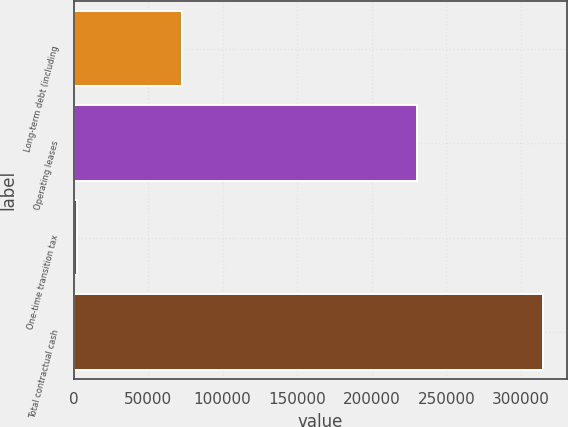Convert chart. <chart><loc_0><loc_0><loc_500><loc_500><bar_chart><fcel>Long-term debt (including<fcel>Operating leases<fcel>One-time transition tax<fcel>Total contractual cash<nl><fcel>72688<fcel>230163<fcel>2448<fcel>314875<nl></chart> 